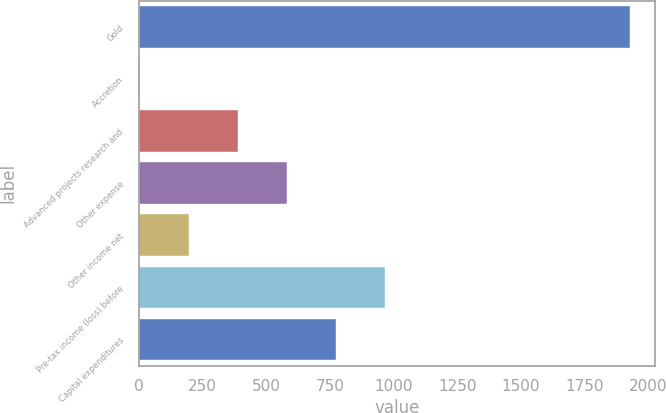Convert chart. <chart><loc_0><loc_0><loc_500><loc_500><bar_chart><fcel>Gold<fcel>Accretion<fcel>Advanced projects research and<fcel>Other expense<fcel>Other income net<fcel>Pre-tax income (loss) before<fcel>Capital expenditures<nl><fcel>1929<fcel>6<fcel>390.6<fcel>582.9<fcel>198.3<fcel>967.5<fcel>775.2<nl></chart> 